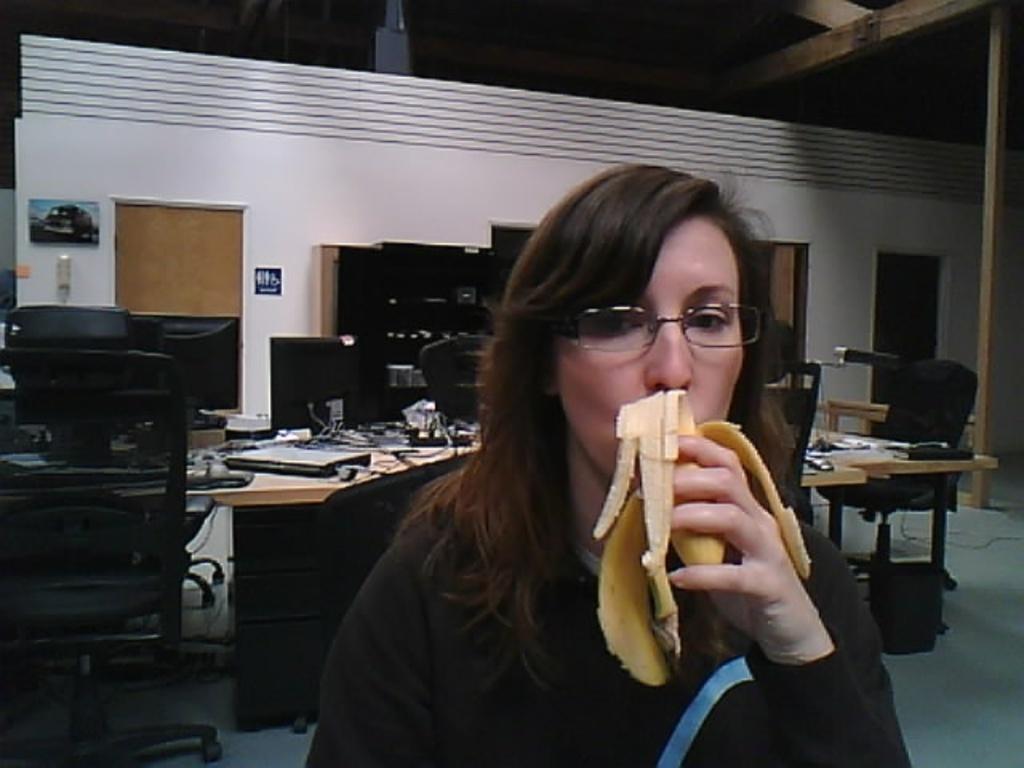Please provide a concise description of this image. In this image in the front there is a woman eating banana. In the background there are monitors, chairs and table, on the table there there are wires and there is a laptop. In the background there are shelves, doors and on the wall there are frames and on the right side there is a wooden stand. 